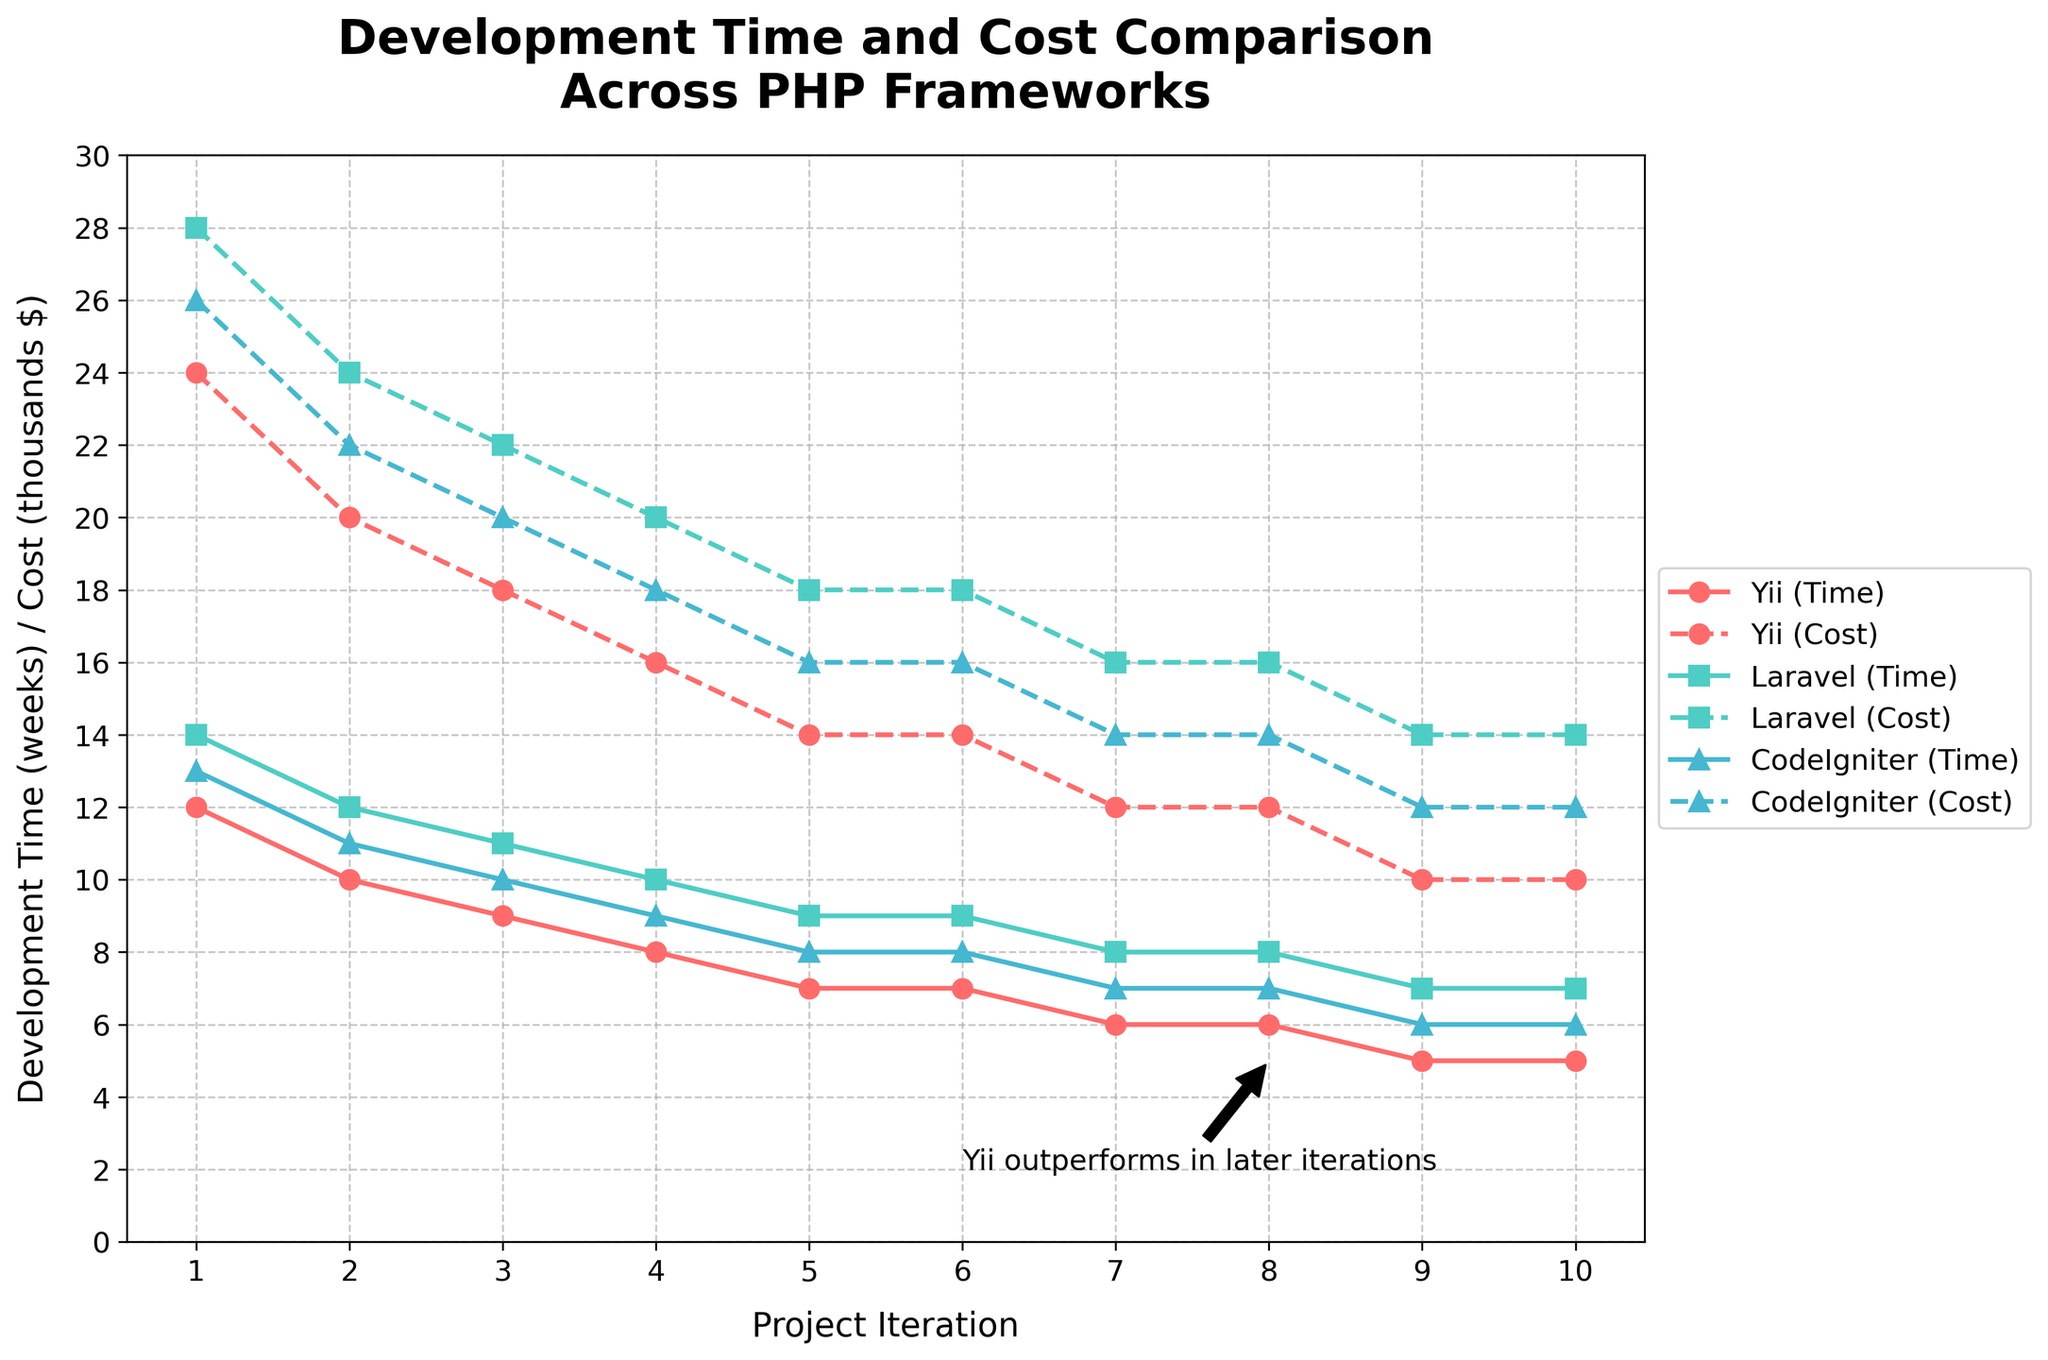Which framework has the lowest development time in the final project iteration? By reviewing the lines representing Development Time (solid lines) in the final iteration (iteration 10), we can see that Yii has the lowest development time in weeks, indicated by the red line.
Answer: Yii How much cost savings does Yii offer compared to Laravel in iteration 4? To find this, look at the dotted lines representing Cost ($) at iteration 4. Yii's cost is 16,000 while Laravel's cost is 20,000. The difference (20,000 - 16,000) gives the cost savings.
Answer: $4,000 Compare the development time trend of Yii and CodeIgniter over the iterations. Both Yii and CodeIgniter reduce their development time consistently per iteration. However, Yii starts decreasing earlier (iteration 1) compared to CodeIgniter and drops to a lower value by the final iteration.
Answer: Yii decreases consistently and more significantly What is the total development cost of Yii over all iterations? The total cost is the sum of Yii costs across all iterations: 24,000 + 20,000 + 18,000 + 16,000 + 14,000 + 14,000 + 12,000 + 12,000 + 10,000 + 10,000. Summing these values gives the total.
Answer: $150,000 Which framework shows a consistent development cost from iteration 6 to iteration 10? Observing the figure, the dotted lines represent cost over iterations. Yii has a constant cost from iteration 6 to 10, clearly seen as a flat horizontal line.
Answer: Yii By how many weeks does Yii development time decrease from iteration 1 to iteration 9? Subtract the development time in iteration 9 from iteration 1 (12 weeks - 5 weeks) to find the decrease.
Answer: 7 weeks Which line color represents Laravel's cost in the chart? The color representing Laravel's cost is turquoise, visible from the dotted lines corresponding to Laravel.
Answer: Turquoise What is the percentage decrease in development time for CodeIgniter from iteration 1 to iteration 7? Calculate the initial and final values (13 weeks to 7 weeks), then the decrease ((13 - 7) / 13) * 100%.
Answer: 46.15% How does Yii’s performance in later iterations compare to Laravel and CodeIgniter concerning both time and cost? In the later iterations (6–10), Yii outperforms both Laravel and CodeIgniter in terms of lower development time and cost consistently, as evidenced by the lines.
Answer: Better in both time and cost 